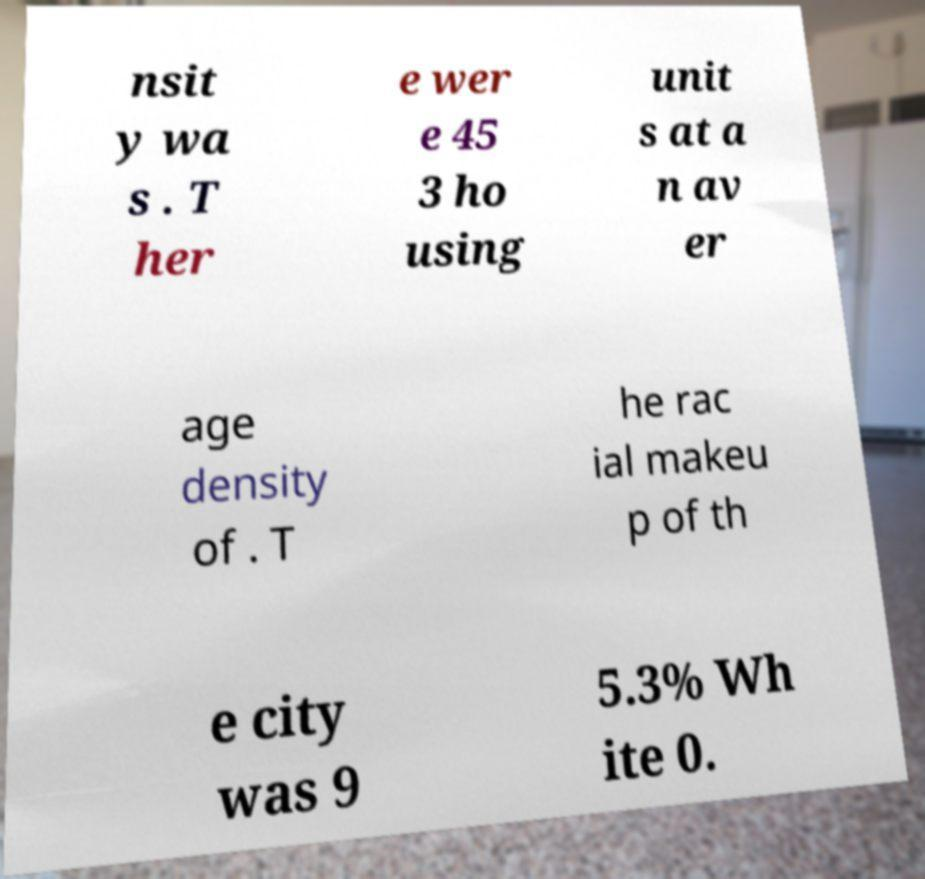Can you read and provide the text displayed in the image?This photo seems to have some interesting text. Can you extract and type it out for me? nsit y wa s . T her e wer e 45 3 ho using unit s at a n av er age density of . T he rac ial makeu p of th e city was 9 5.3% Wh ite 0. 